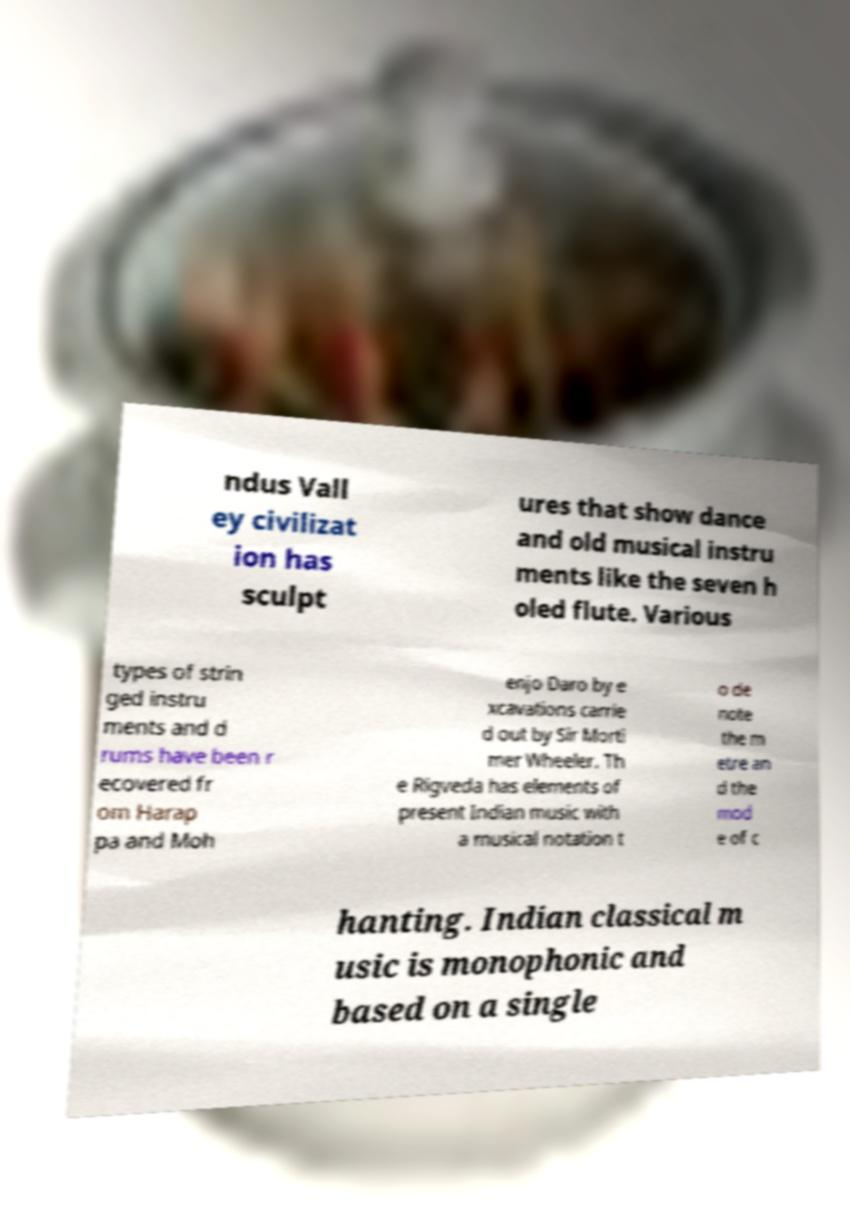Can you read and provide the text displayed in the image?This photo seems to have some interesting text. Can you extract and type it out for me? ndus Vall ey civilizat ion has sculpt ures that show dance and old musical instru ments like the seven h oled flute. Various types of strin ged instru ments and d rums have been r ecovered fr om Harap pa and Moh enjo Daro by e xcavations carrie d out by Sir Morti mer Wheeler. Th e Rigveda has elements of present Indian music with a musical notation t o de note the m etre an d the mod e of c hanting. Indian classical m usic is monophonic and based on a single 